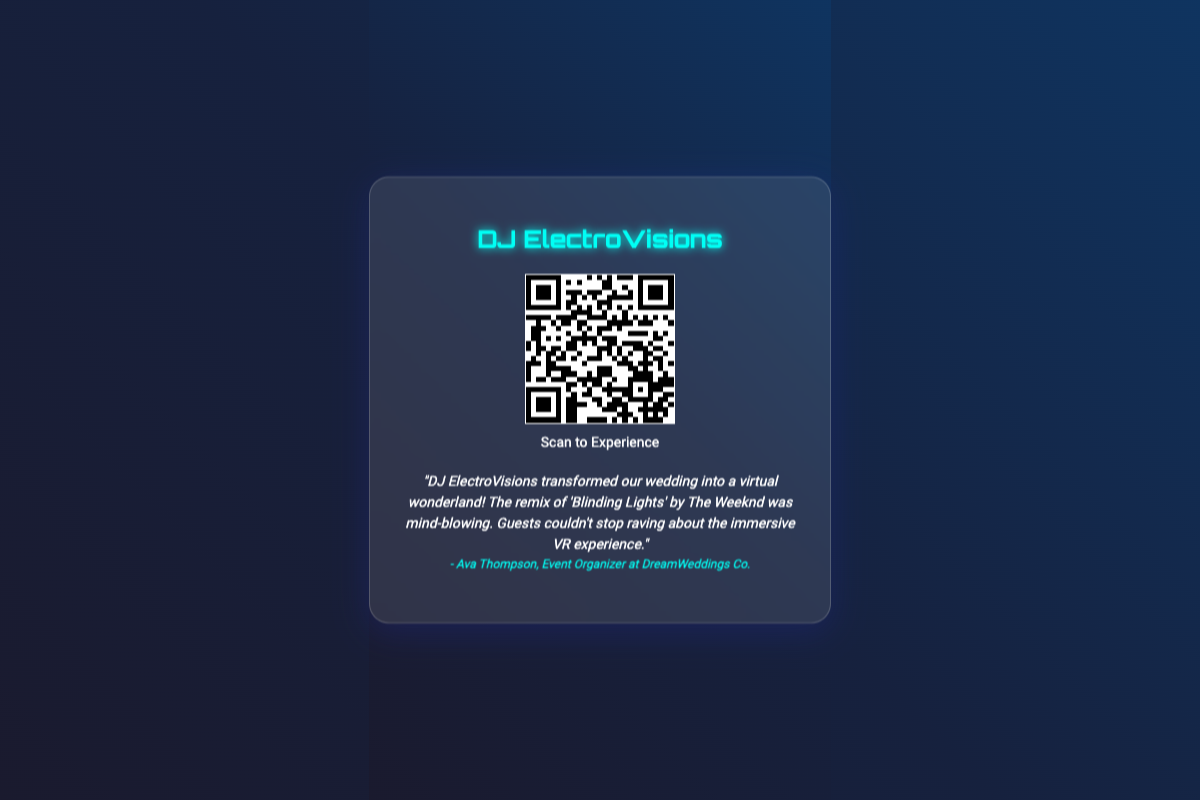What is the name displayed on the business card? The name at the top of the business card indicates the brand identity of the DJ.
Answer: DJ ElectroVisions What is the QR code destination link? The QR code is a direct link to a sample experience, highlighting the work of the DJ.
Answer: https://www.virtualdjremixes.com/sample-experience Who gave the testimonial? The author of the testimonial provides credibility and insight into the services offered by the DJ.
Answer: Ava Thompson What event was transformed by DJ ElectroVisions? This question refers to the specific type of event that utilized the DJ's services, as mentioned in the testimonial.
Answer: wedding Which song was remixed by DJ ElectroVisions? The specific song mentioned in the testimonial showcases the DJ's remixing style and capability.
Answer: Blinding Lights 